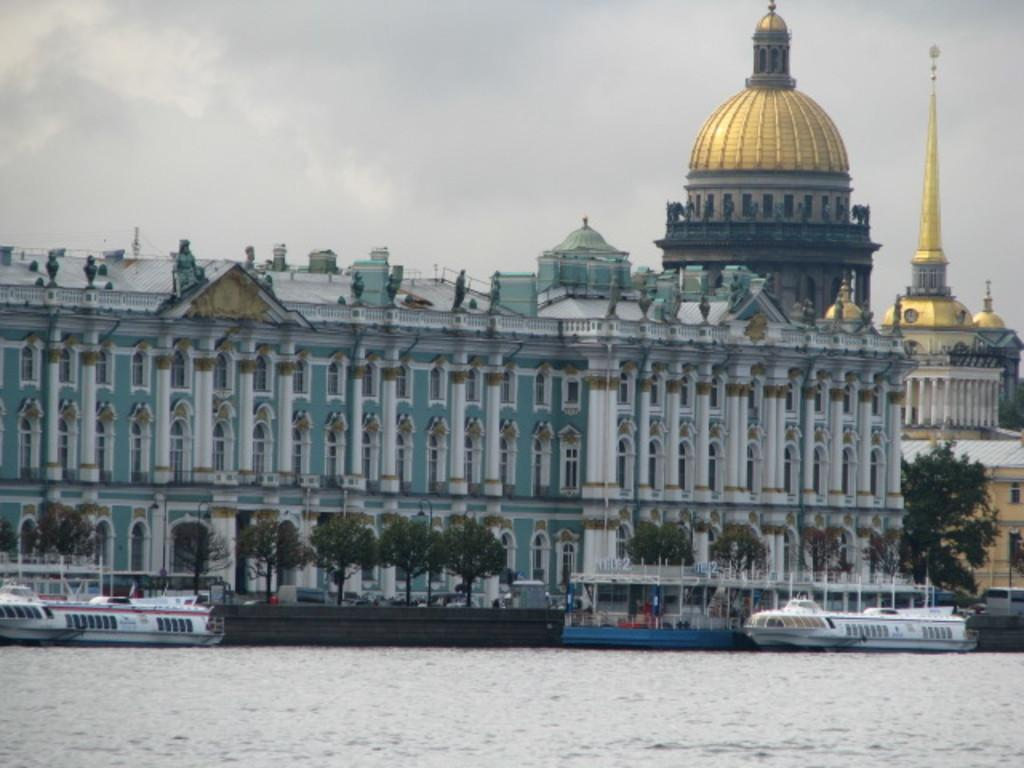What can be seen on the water in the image? There are ships on the water in the image. What type of structures are present in the image? There are buildings in the image. What part of the buildings can be seen in the image? There are windows visible in the image. What type of vegetation is present in the image? There are trees in the image. What type of symbols can be seen in the image? There are flags in the image. What type of vertical structures are present in the image? There are poles in the image. What can be seen in the background of the image? The sky is visible in the background of the image. Where is the goat located in the image? There is no goat present in the image. What type of surface can be seen on the sidewalk in the image? There is no sidewalk present in the image. 